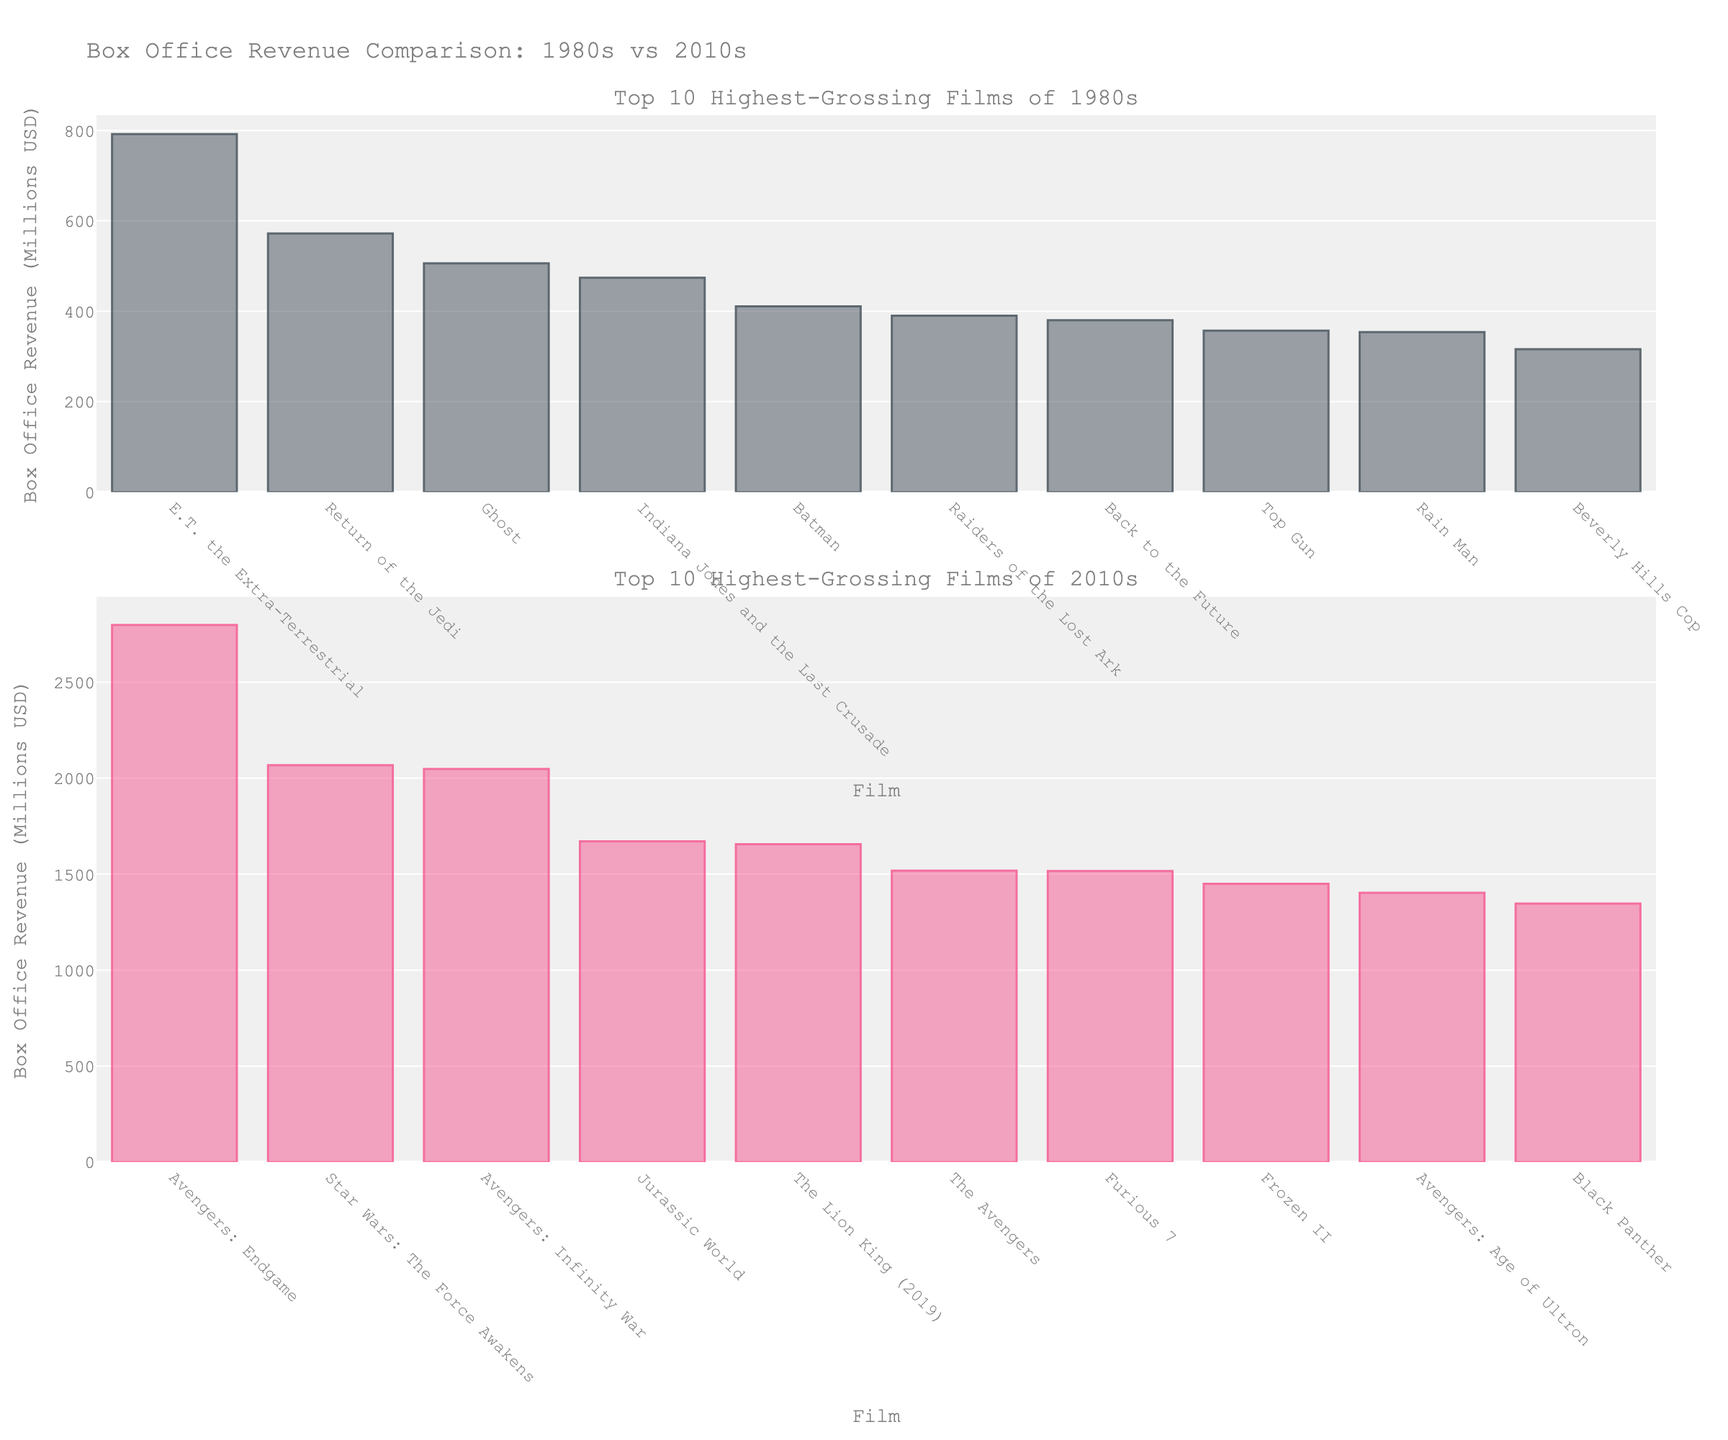What is the difference in box office revenue between the highest-grossing films of the 1980s and the 2010s? To find the difference, look at the highest-grossing film of each decade. "E.T. the Extra-Terrestrial" for the 1980s with $792 million and "Avengers: Endgame" for the 2010s with $2798 million. Subtract the box office of "E.T. the Extra-Terrestrial" from "Avengers: Endgame": 2798 - 792 = 2006
Answer: 2006 Which decade has the higher total box office revenue for the top 10 highest-grossing films? Sum the box office revenues of the top 10 films from each decade. The 1980s have: 792 + 572 + 390 + 380 + 474 + 411 + 506 + 316 + 354 + 357 = 4552 million USD. The 2010s have: 2798 + 2068 + 2048 + 1671 + 1656 + 1518 + 1516 + 1450 + 1403 + 1347 = 17475 million USD. Compare the totals: 17475 is greater than 4552
Answer: 2010s How many films from the 2010s exceeded $2000 million in box office revenue? Look at the bar heights for the 2010s and count the films that are at or above the 2000 million mark. These are: "Avengers: Endgame", "Star Wars: The Force Awakens", and "Avengers: Infinity War". Total = 3
Answer: 3 What is the average box office revenue of the top 5 highest-grossing films from the 1980s? First, identify the top 5 films from the 1980s by box office revenue: "E.T. the Extra-Terrestrial" ($792M), "Return of the Jedi" ($572M), "Ghost" ($506M), "Indiana Jones and the Last Crusade" ($474M), and "Batman" ($411M). Sum these revenues: 792 + 572 + 506 + 474 + 411 = 2755. Divide by 5: 2755 / 5 = 551
Answer: 551 Which film from the 1980s has the smallest box office revenue, and what is that amount? Look at the shortest bar in the 1980s chart, which corresponds to "Beverly Hills Cop" with $316 million
Answer: "Beverly Hills Cop", $316 million Compare the box office revenues of "Star Wars: The Force Awakens" and "Return of the Jedi". Which one is higher and by how much? Identify the revenues from the bars: "Star Wars: The Force Awakens" ($2068M) and "Return of the Jedi" ($572M). Subtract the revenue of "Return of the Jedi" from "Star Wars: The Force Awakens": 2068 - 572 = 1496
Answer: "Star Wars: The Force Awakens" by 1496 Which film from the 1980s is closest in box office revenue to "Black Panther" from the 2010s? Identify "Black Panther"'s revenue from the chart (1347 million). The closest film from the 1980s is "E.T. the Extra-Terrestrial" with $792 million, but none of the 1980s films reach close to "Black Panther". So the phrase "closest" is understood within the limitations of the 1980s films' revenues.
Answer: "E.T. the Extra-Terrestrial" What is the median box office revenue for the top 10 films of 2010s? Arrange the revenues in ascending order: 1347, 1403, 1450, 1516, 1518, 1656, 1671, 2048, 2068, 2798. The median is the average of the 5th and 6th values: (1518 + 1656) / 2 = 1587
Answer: 1587 